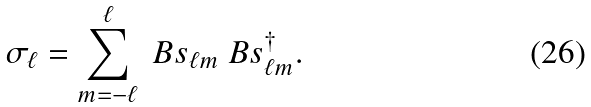<formula> <loc_0><loc_0><loc_500><loc_500>\sigma _ { \ell } = \sum _ { m = - \ell } ^ { \ell } \ B s _ { \ell m } \ B s _ { \ell m } ^ { \dag } .</formula> 